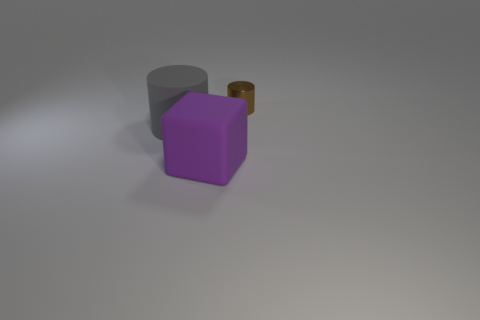Subtract all cylinders. How many objects are left? 1 Subtract 1 cylinders. How many cylinders are left? 1 Add 3 brown rubber things. How many objects exist? 6 Subtract all red cylinders. Subtract all blue cubes. How many cylinders are left? 2 Subtract all cyan blocks. How many brown cylinders are left? 1 Subtract all large cyan metal cylinders. Subtract all purple matte things. How many objects are left? 2 Add 1 tiny brown metal cylinders. How many tiny brown metal cylinders are left? 2 Add 3 metal things. How many metal things exist? 4 Subtract 1 gray cylinders. How many objects are left? 2 